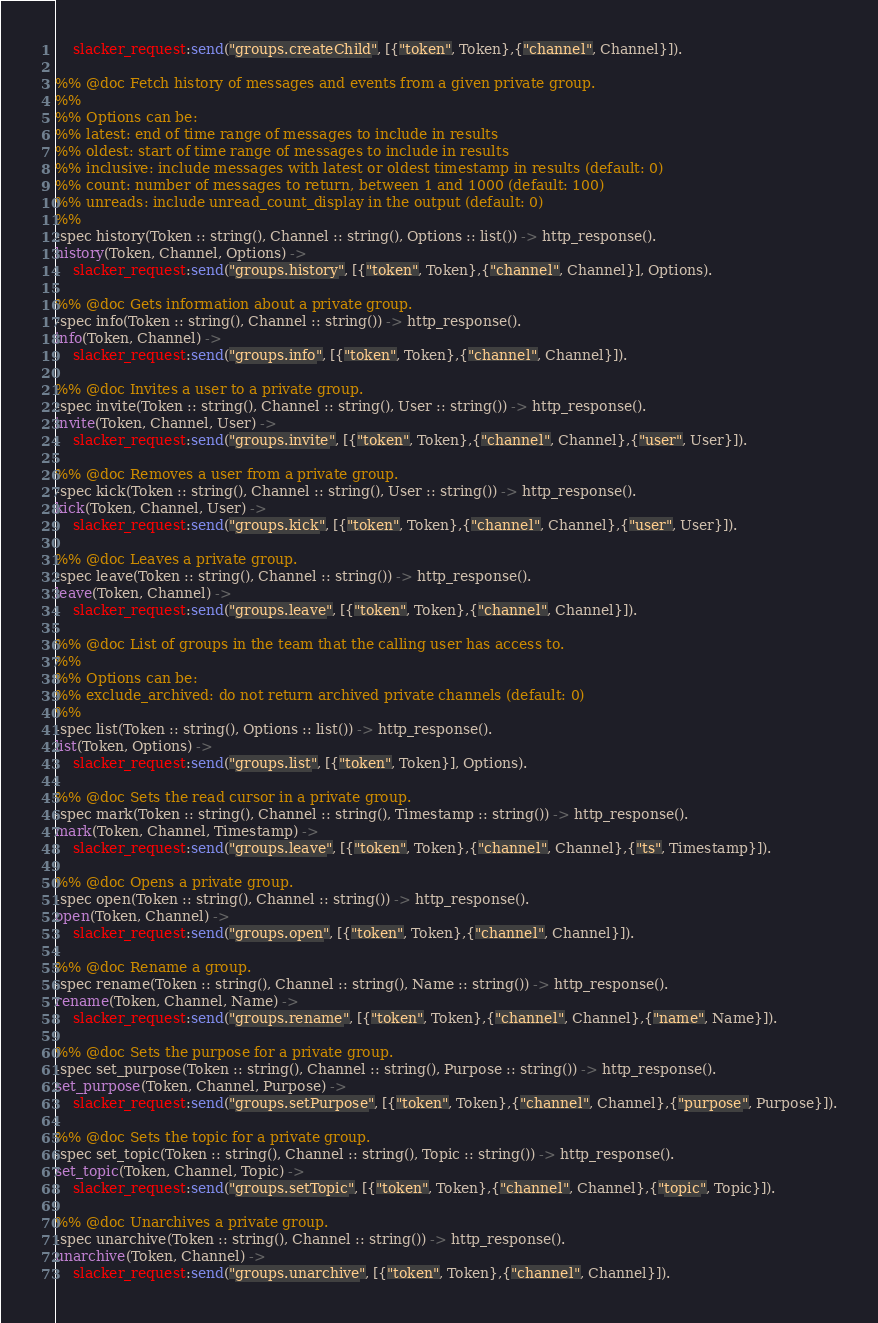Convert code to text. <code><loc_0><loc_0><loc_500><loc_500><_Erlang_>    slacker_request:send("groups.createChild", [{"token", Token},{"channel", Channel}]).

%% @doc Fetch history of messages and events from a given private group.
%%
%% Options can be:
%% latest: end of time range of messages to include in results
%% oldest: start of time range of messages to include in results
%% inclusive: include messages with latest or oldest timestamp in results (default: 0)
%% count: number of messages to return, between 1 and 1000 (default: 100)
%% unreads: include unread_count_display in the output (default: 0)
%%
-spec history(Token :: string(), Channel :: string(), Options :: list()) -> http_response().
history(Token, Channel, Options) ->
    slacker_request:send("groups.history", [{"token", Token},{"channel", Channel}], Options).

%% @doc Gets information about a private group.
-spec info(Token :: string(), Channel :: string()) -> http_response().
info(Token, Channel) ->
    slacker_request:send("groups.info", [{"token", Token},{"channel", Channel}]).

%% @doc Invites a user to a private group.
-spec invite(Token :: string(), Channel :: string(), User :: string()) -> http_response().
invite(Token, Channel, User) ->
    slacker_request:send("groups.invite", [{"token", Token},{"channel", Channel},{"user", User}]).

%% @doc Removes a user from a private group.
-spec kick(Token :: string(), Channel :: string(), User :: string()) -> http_response().
kick(Token, Channel, User) ->
    slacker_request:send("groups.kick", [{"token", Token},{"channel", Channel},{"user", User}]).

%% @doc Leaves a private group.
-spec leave(Token :: string(), Channel :: string()) -> http_response().
leave(Token, Channel) ->
    slacker_request:send("groups.leave", [{"token", Token},{"channel", Channel}]).

%% @doc List of groups in the team that the calling user has access to.
%%
%% Options can be:
%% exclude_archived: do not return archived private channels (default: 0)
%%
-spec list(Token :: string(), Options :: list()) -> http_response().
list(Token, Options) ->
    slacker_request:send("groups.list", [{"token", Token}], Options).

%% @doc Sets the read cursor in a private group.
-spec mark(Token :: string(), Channel :: string(), Timestamp :: string()) -> http_response().
mark(Token, Channel, Timestamp) ->
    slacker_request:send("groups.leave", [{"token", Token},{"channel", Channel},{"ts", Timestamp}]).

%% @doc Opens a private group.
-spec open(Token :: string(), Channel :: string()) -> http_response().
open(Token, Channel) ->
    slacker_request:send("groups.open", [{"token", Token},{"channel", Channel}]).

%% @doc Rename a group.
-spec rename(Token :: string(), Channel :: string(), Name :: string()) -> http_response().
rename(Token, Channel, Name) ->
    slacker_request:send("groups.rename", [{"token", Token},{"channel", Channel},{"name", Name}]).

%% @doc Sets the purpose for a private group.
-spec set_purpose(Token :: string(), Channel :: string(), Purpose :: string()) -> http_response().
set_purpose(Token, Channel, Purpose) ->
    slacker_request:send("groups.setPurpose", [{"token", Token},{"channel", Channel},{"purpose", Purpose}]).

%% @doc Sets the topic for a private group.
-spec set_topic(Token :: string(), Channel :: string(), Topic :: string()) -> http_response().
set_topic(Token, Channel, Topic) ->
    slacker_request:send("groups.setTopic", [{"token", Token},{"channel", Channel},{"topic", Topic}]).

%% @doc Unarchives a private group.
-spec unarchive(Token :: string(), Channel :: string()) -> http_response().
unarchive(Token, Channel) ->
    slacker_request:send("groups.unarchive", [{"token", Token},{"channel", Channel}]).
</code> 